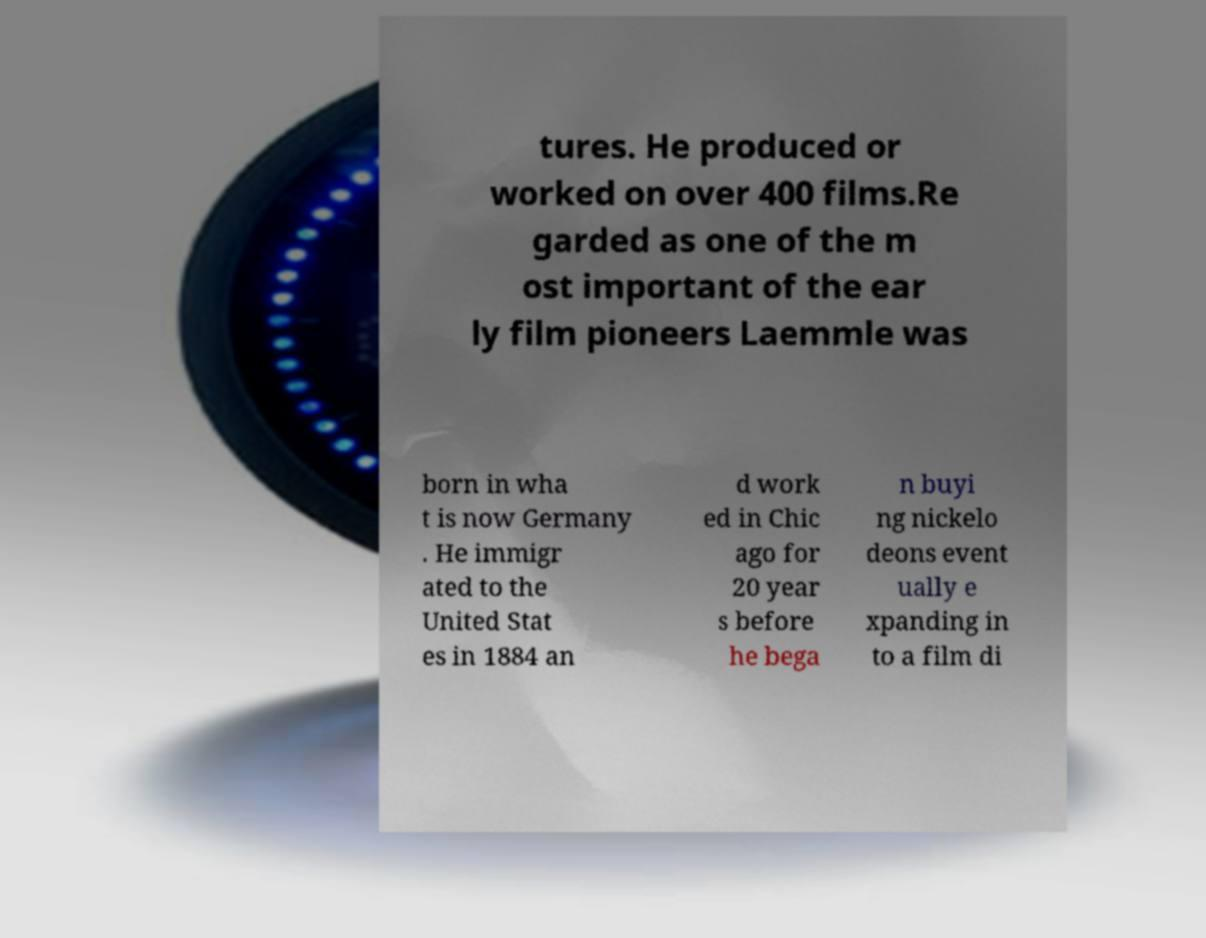What messages or text are displayed in this image? I need them in a readable, typed format. tures. He produced or worked on over 400 films.Re garded as one of the m ost important of the ear ly film pioneers Laemmle was born in wha t is now Germany . He immigr ated to the United Stat es in 1884 an d work ed in Chic ago for 20 year s before he bega n buyi ng nickelo deons event ually e xpanding in to a film di 